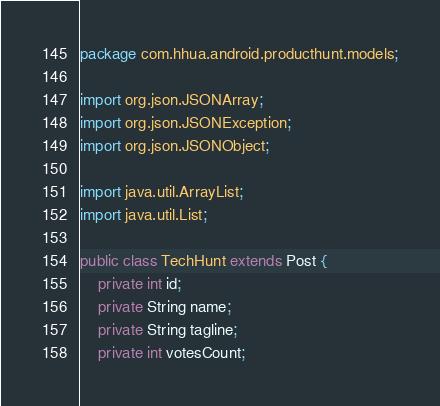<code> <loc_0><loc_0><loc_500><loc_500><_Java_>package com.hhua.android.producthunt.models;

import org.json.JSONArray;
import org.json.JSONException;
import org.json.JSONObject;

import java.util.ArrayList;
import java.util.List;

public class TechHunt extends Post {
    private int id;
    private String name;
    private String tagline;
    private int votesCount;</code> 